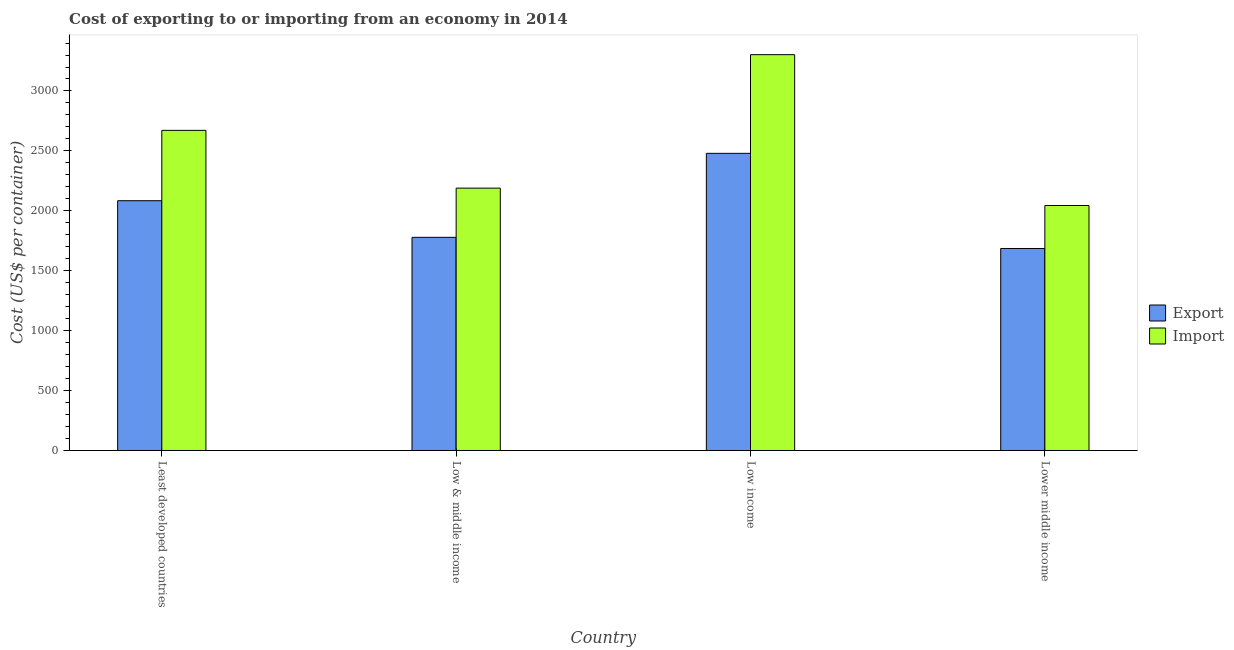Are the number of bars on each tick of the X-axis equal?
Ensure brevity in your answer.  Yes. How many bars are there on the 3rd tick from the left?
Provide a succinct answer. 2. How many bars are there on the 4th tick from the right?
Provide a succinct answer. 2. What is the label of the 3rd group of bars from the left?
Offer a very short reply. Low income. In how many cases, is the number of bars for a given country not equal to the number of legend labels?
Your answer should be compact. 0. What is the import cost in Least developed countries?
Give a very brief answer. 2671.37. Across all countries, what is the maximum import cost?
Make the answer very short. 3303.03. Across all countries, what is the minimum export cost?
Give a very brief answer. 1685.55. In which country was the export cost minimum?
Keep it short and to the point. Lower middle income. What is the total export cost in the graph?
Ensure brevity in your answer.  8028.32. What is the difference between the export cost in Low & middle income and that in Lower middle income?
Your answer should be very brief. 93.21. What is the difference between the export cost in Low income and the import cost in Least developed countries?
Your answer should be very brief. -191.71. What is the average import cost per country?
Give a very brief answer. 2551.99. What is the difference between the import cost and export cost in Low & middle income?
Offer a very short reply. 410.54. In how many countries, is the import cost greater than 2300 US$?
Ensure brevity in your answer.  2. What is the ratio of the import cost in Low income to that in Lower middle income?
Ensure brevity in your answer.  1.62. Is the export cost in Low & middle income less than that in Lower middle income?
Provide a succinct answer. No. What is the difference between the highest and the second highest import cost?
Offer a terse response. 631.66. What is the difference between the highest and the lowest import cost?
Offer a very short reply. 1258.77. In how many countries, is the export cost greater than the average export cost taken over all countries?
Your response must be concise. 2. Is the sum of the export cost in Low income and Lower middle income greater than the maximum import cost across all countries?
Provide a short and direct response. Yes. What does the 2nd bar from the left in Lower middle income represents?
Provide a succinct answer. Import. What does the 1st bar from the right in Low & middle income represents?
Offer a very short reply. Import. Are all the bars in the graph horizontal?
Provide a short and direct response. No. How many countries are there in the graph?
Your answer should be very brief. 4. What is the difference between two consecutive major ticks on the Y-axis?
Keep it short and to the point. 500. Are the values on the major ticks of Y-axis written in scientific E-notation?
Offer a terse response. No. Does the graph contain grids?
Make the answer very short. No. Where does the legend appear in the graph?
Offer a very short reply. Center right. How many legend labels are there?
Your response must be concise. 2. What is the title of the graph?
Offer a terse response. Cost of exporting to or importing from an economy in 2014. What is the label or title of the Y-axis?
Offer a terse response. Cost (US$ per container). What is the Cost (US$ per container) in Export in Least developed countries?
Your response must be concise. 2084.37. What is the Cost (US$ per container) of Import in Least developed countries?
Your answer should be compact. 2671.37. What is the Cost (US$ per container) in Export in Low & middle income?
Your response must be concise. 1778.75. What is the Cost (US$ per container) of Import in Low & middle income?
Provide a short and direct response. 2189.29. What is the Cost (US$ per container) in Export in Low income?
Provide a succinct answer. 2479.66. What is the Cost (US$ per container) of Import in Low income?
Your response must be concise. 3303.03. What is the Cost (US$ per container) in Export in Lower middle income?
Provide a succinct answer. 1685.55. What is the Cost (US$ per container) in Import in Lower middle income?
Provide a short and direct response. 2044.26. Across all countries, what is the maximum Cost (US$ per container) of Export?
Your answer should be compact. 2479.66. Across all countries, what is the maximum Cost (US$ per container) of Import?
Make the answer very short. 3303.03. Across all countries, what is the minimum Cost (US$ per container) in Export?
Keep it short and to the point. 1685.55. Across all countries, what is the minimum Cost (US$ per container) of Import?
Offer a very short reply. 2044.26. What is the total Cost (US$ per container) of Export in the graph?
Provide a succinct answer. 8028.32. What is the total Cost (US$ per container) in Import in the graph?
Provide a short and direct response. 1.02e+04. What is the difference between the Cost (US$ per container) in Export in Least developed countries and that in Low & middle income?
Give a very brief answer. 305.62. What is the difference between the Cost (US$ per container) of Import in Least developed countries and that in Low & middle income?
Offer a very short reply. 482.08. What is the difference between the Cost (US$ per container) of Export in Least developed countries and that in Low income?
Keep it short and to the point. -395.29. What is the difference between the Cost (US$ per container) of Import in Least developed countries and that in Low income?
Keep it short and to the point. -631.66. What is the difference between the Cost (US$ per container) of Export in Least developed countries and that in Lower middle income?
Offer a very short reply. 398.82. What is the difference between the Cost (US$ per container) in Import in Least developed countries and that in Lower middle income?
Ensure brevity in your answer.  627.11. What is the difference between the Cost (US$ per container) in Export in Low & middle income and that in Low income?
Ensure brevity in your answer.  -700.9. What is the difference between the Cost (US$ per container) in Import in Low & middle income and that in Low income?
Offer a very short reply. -1113.74. What is the difference between the Cost (US$ per container) of Export in Low & middle income and that in Lower middle income?
Make the answer very short. 93.21. What is the difference between the Cost (US$ per container) in Import in Low & middle income and that in Lower middle income?
Offer a very short reply. 145.03. What is the difference between the Cost (US$ per container) in Export in Low income and that in Lower middle income?
Give a very brief answer. 794.11. What is the difference between the Cost (US$ per container) of Import in Low income and that in Lower middle income?
Provide a succinct answer. 1258.77. What is the difference between the Cost (US$ per container) of Export in Least developed countries and the Cost (US$ per container) of Import in Low & middle income?
Keep it short and to the point. -104.92. What is the difference between the Cost (US$ per container) of Export in Least developed countries and the Cost (US$ per container) of Import in Low income?
Provide a succinct answer. -1218.66. What is the difference between the Cost (US$ per container) in Export in Least developed countries and the Cost (US$ per container) in Import in Lower middle income?
Provide a short and direct response. 40.11. What is the difference between the Cost (US$ per container) of Export in Low & middle income and the Cost (US$ per container) of Import in Low income?
Ensure brevity in your answer.  -1524.28. What is the difference between the Cost (US$ per container) in Export in Low & middle income and the Cost (US$ per container) in Import in Lower middle income?
Ensure brevity in your answer.  -265.51. What is the difference between the Cost (US$ per container) in Export in Low income and the Cost (US$ per container) in Import in Lower middle income?
Keep it short and to the point. 435.39. What is the average Cost (US$ per container) in Export per country?
Make the answer very short. 2007.08. What is the average Cost (US$ per container) of Import per country?
Keep it short and to the point. 2551.99. What is the difference between the Cost (US$ per container) of Export and Cost (US$ per container) of Import in Least developed countries?
Offer a terse response. -587. What is the difference between the Cost (US$ per container) of Export and Cost (US$ per container) of Import in Low & middle income?
Your answer should be compact. -410.54. What is the difference between the Cost (US$ per container) of Export and Cost (US$ per container) of Import in Low income?
Keep it short and to the point. -823.38. What is the difference between the Cost (US$ per container) in Export and Cost (US$ per container) in Import in Lower middle income?
Ensure brevity in your answer.  -358.72. What is the ratio of the Cost (US$ per container) of Export in Least developed countries to that in Low & middle income?
Offer a terse response. 1.17. What is the ratio of the Cost (US$ per container) in Import in Least developed countries to that in Low & middle income?
Your answer should be very brief. 1.22. What is the ratio of the Cost (US$ per container) of Export in Least developed countries to that in Low income?
Keep it short and to the point. 0.84. What is the ratio of the Cost (US$ per container) in Import in Least developed countries to that in Low income?
Provide a short and direct response. 0.81. What is the ratio of the Cost (US$ per container) of Export in Least developed countries to that in Lower middle income?
Provide a short and direct response. 1.24. What is the ratio of the Cost (US$ per container) of Import in Least developed countries to that in Lower middle income?
Make the answer very short. 1.31. What is the ratio of the Cost (US$ per container) in Export in Low & middle income to that in Low income?
Keep it short and to the point. 0.72. What is the ratio of the Cost (US$ per container) in Import in Low & middle income to that in Low income?
Your answer should be compact. 0.66. What is the ratio of the Cost (US$ per container) in Export in Low & middle income to that in Lower middle income?
Offer a very short reply. 1.06. What is the ratio of the Cost (US$ per container) of Import in Low & middle income to that in Lower middle income?
Your answer should be very brief. 1.07. What is the ratio of the Cost (US$ per container) in Export in Low income to that in Lower middle income?
Give a very brief answer. 1.47. What is the ratio of the Cost (US$ per container) of Import in Low income to that in Lower middle income?
Your response must be concise. 1.62. What is the difference between the highest and the second highest Cost (US$ per container) of Export?
Your answer should be very brief. 395.29. What is the difference between the highest and the second highest Cost (US$ per container) of Import?
Provide a succinct answer. 631.66. What is the difference between the highest and the lowest Cost (US$ per container) in Export?
Offer a terse response. 794.11. What is the difference between the highest and the lowest Cost (US$ per container) in Import?
Provide a succinct answer. 1258.77. 